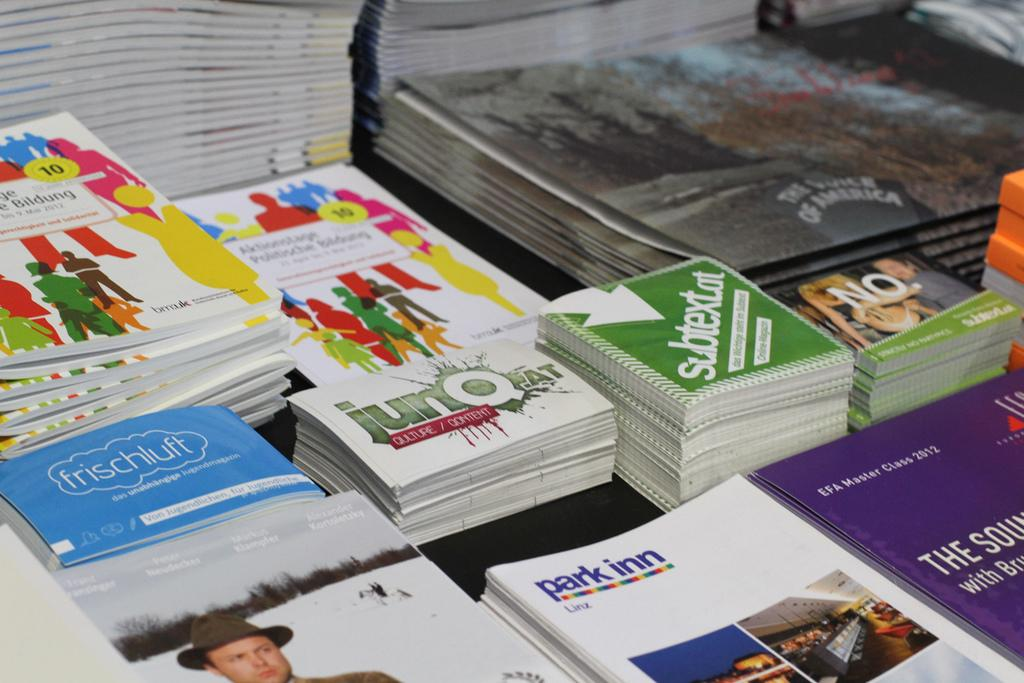<image>
Offer a succinct explanation of the picture presented. Brochures about park inn sit on a table with other brochures and postcards. 